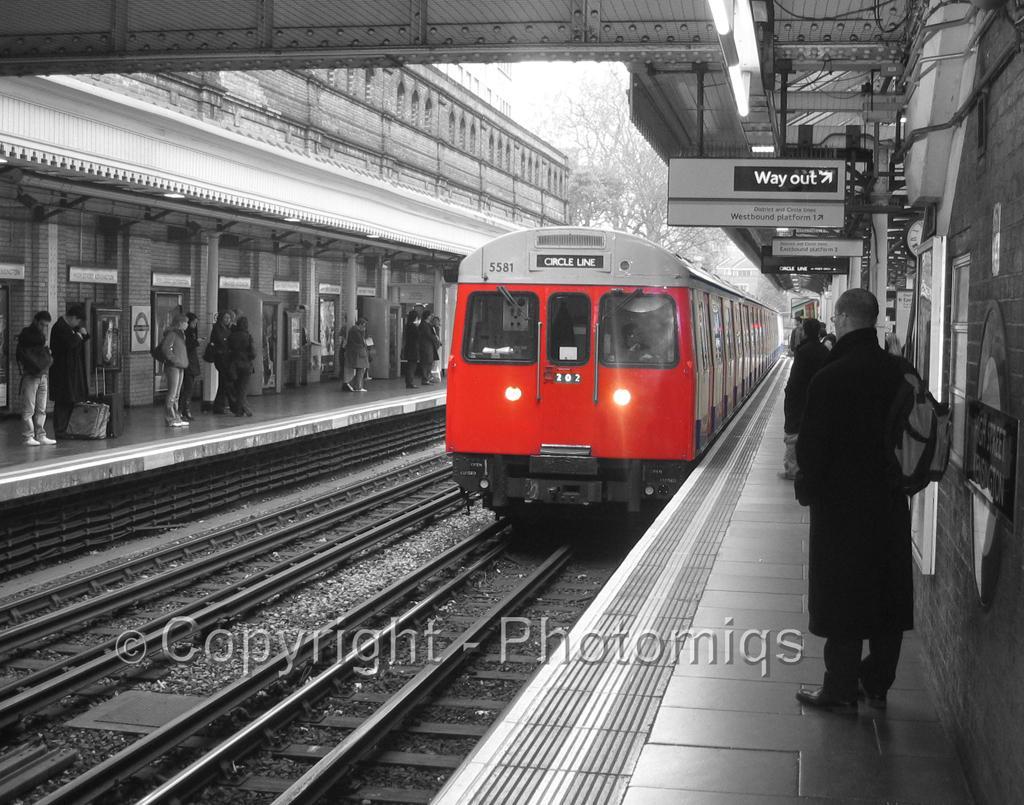How would you summarize this image in a sentence or two? There are railway tracks. On the railway track there is a train with lights. On the sides there are platforms. On the platforms there are people. Also there are pillars. On the right side there are boards hanged on the platform. In the back there are trees. 